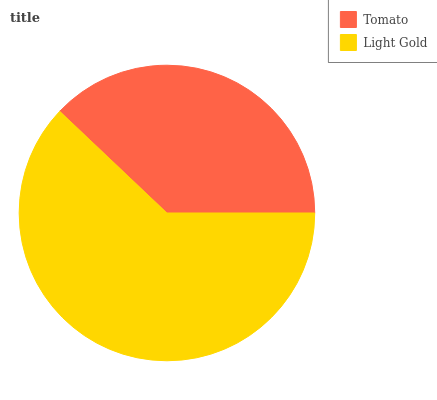Is Tomato the minimum?
Answer yes or no. Yes. Is Light Gold the maximum?
Answer yes or no. Yes. Is Light Gold the minimum?
Answer yes or no. No. Is Light Gold greater than Tomato?
Answer yes or no. Yes. Is Tomato less than Light Gold?
Answer yes or no. Yes. Is Tomato greater than Light Gold?
Answer yes or no. No. Is Light Gold less than Tomato?
Answer yes or no. No. Is Light Gold the high median?
Answer yes or no. Yes. Is Tomato the low median?
Answer yes or no. Yes. Is Tomato the high median?
Answer yes or no. No. Is Light Gold the low median?
Answer yes or no. No. 